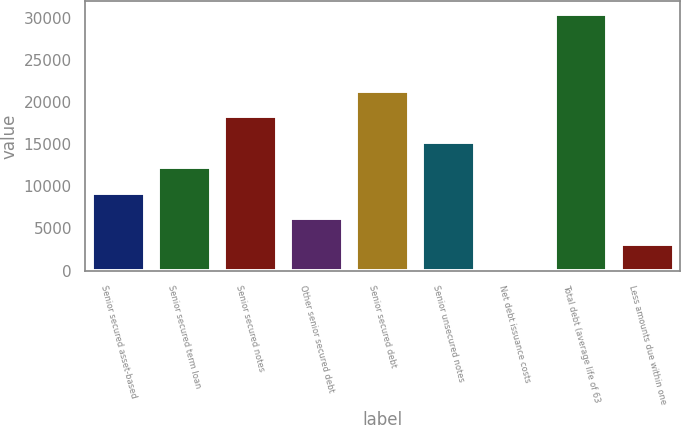Convert chart to OTSL. <chart><loc_0><loc_0><loc_500><loc_500><bar_chart><fcel>Senior secured asset-based<fcel>Senior secured term loan<fcel>Senior secured notes<fcel>Other senior secured debt<fcel>Senior secured debt<fcel>Senior unsecured notes<fcel>Net debt issuance costs<fcel>Total debt (average life of 63<fcel>Less amounts due within one<nl><fcel>9263.3<fcel>12295.4<fcel>18359.6<fcel>6231.2<fcel>21391.7<fcel>15327.5<fcel>167<fcel>30488<fcel>3199.1<nl></chart> 